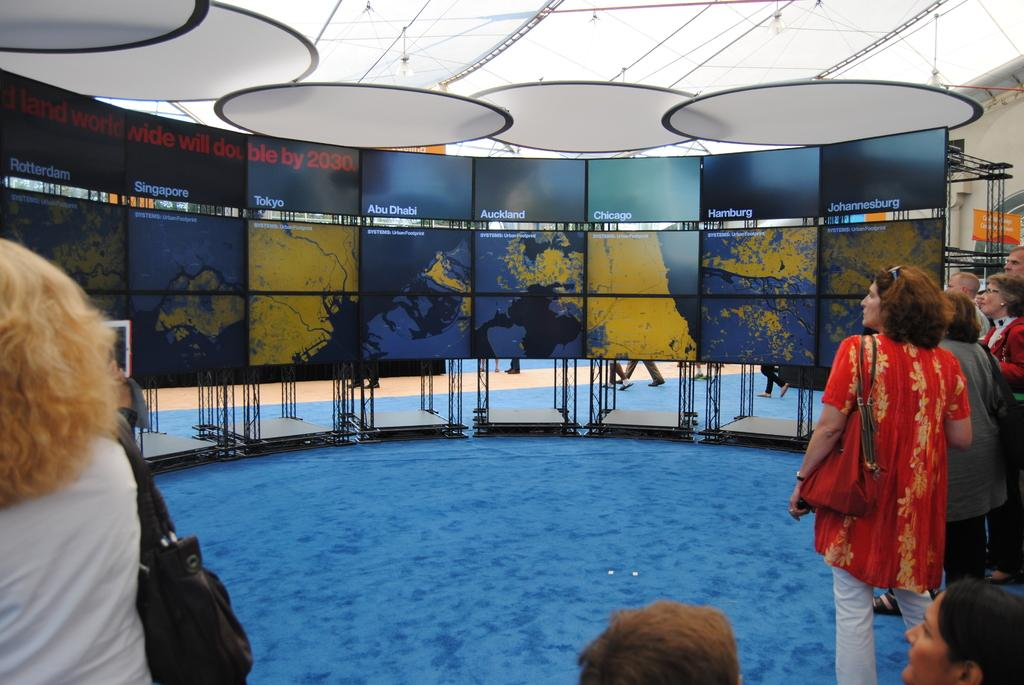How many people are in the image? There are people in the image, but the exact number is not specified. What can be seen on the boards in the image? There are boards with text written on them in the image. What type of shoes are the people wearing in the image? There is no information about the type of shoes the people are wearing in the image. What act are the people performing in the image? There is no specific act being performed by the people in the image. How far do the people stretch in the image? There is no indication of the people stretching in the image. 